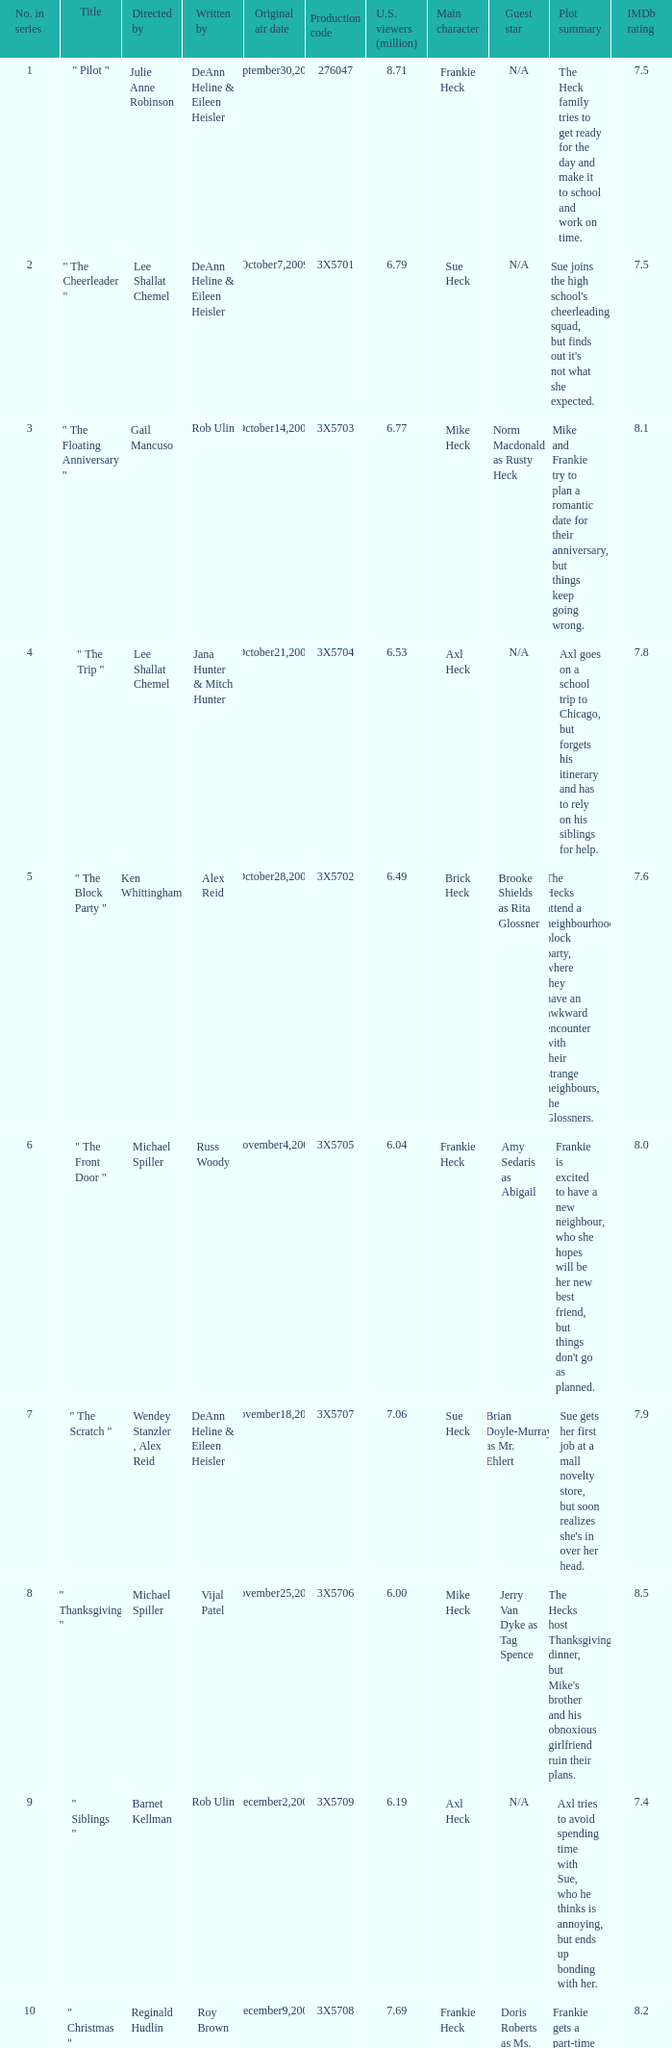What is the title of the episode Alex Reid directed? "The Final Four". 